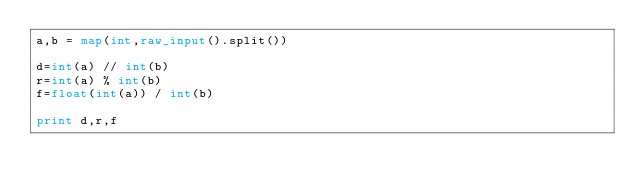<code> <loc_0><loc_0><loc_500><loc_500><_Python_>a,b = map(int,raw_input().split())

d=int(a) // int(b)  
r=int(a) % int(b)
f=float(int(a)) / int(b)

print d,r,f</code> 